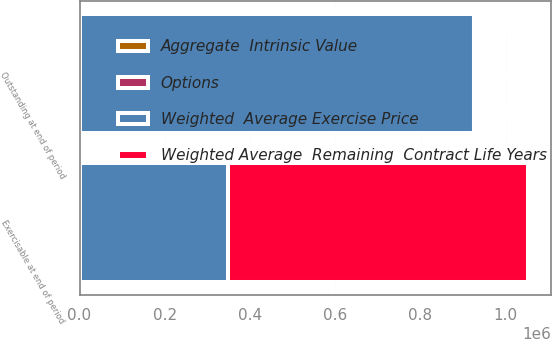<chart> <loc_0><loc_0><loc_500><loc_500><stacked_bar_chart><ecel><fcel>Outstanding at end of period<fcel>Exercisable at end of period<nl><fcel>Weighted Average  Remaining  Contract Life Years<fcel>299.81<fcel>703879<nl><fcel>Aggregate  Intrinsic Value<fcel>299.81<fcel>149.55<nl><fcel>Options<fcel>5.18<fcel>3.76<nl><fcel>Weighted  Average Exercise Price<fcel>925978<fcel>348737<nl></chart> 